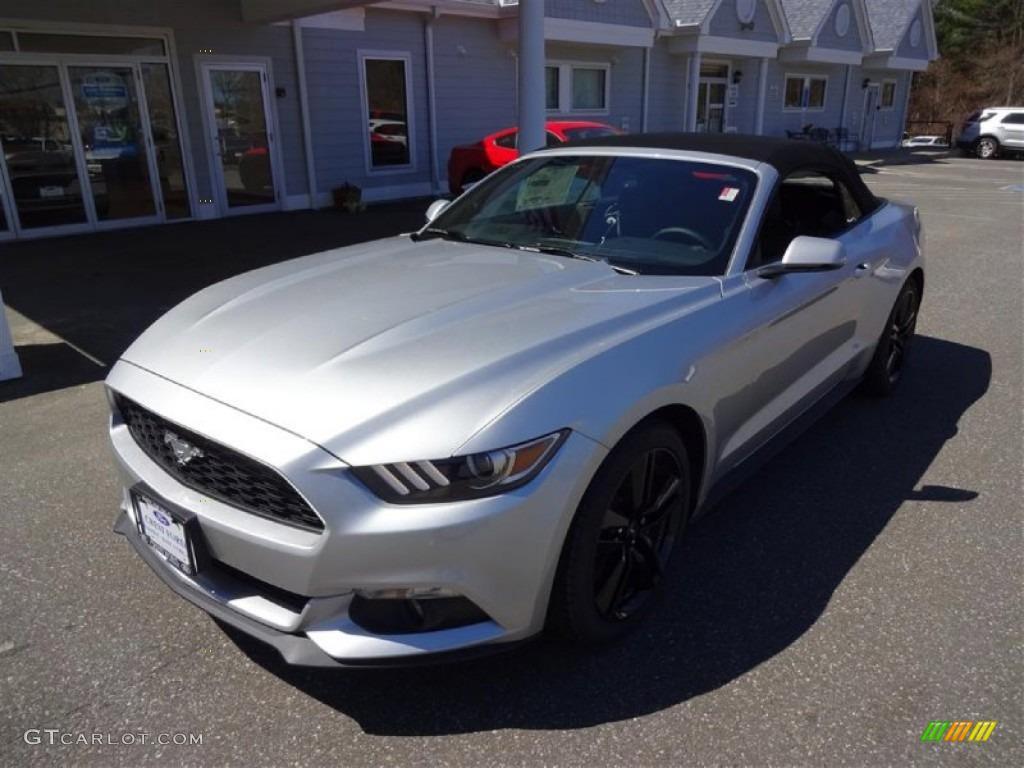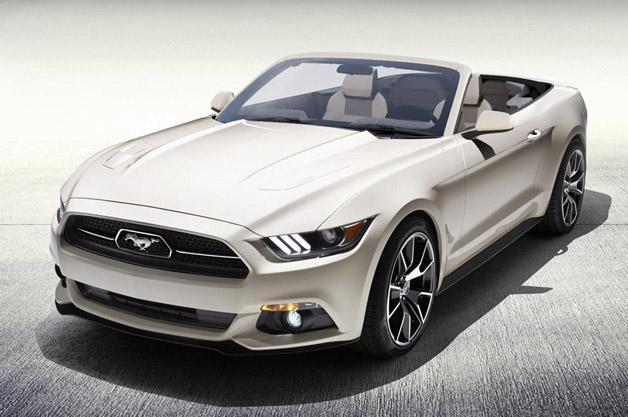The first image is the image on the left, the second image is the image on the right. Evaluate the accuracy of this statement regarding the images: "One convertible is angled towards the front and one is shown from the side.". Is it true? Answer yes or no. No. The first image is the image on the left, the second image is the image on the right. Given the left and right images, does the statement "All cars are facing left." hold true? Answer yes or no. Yes. 